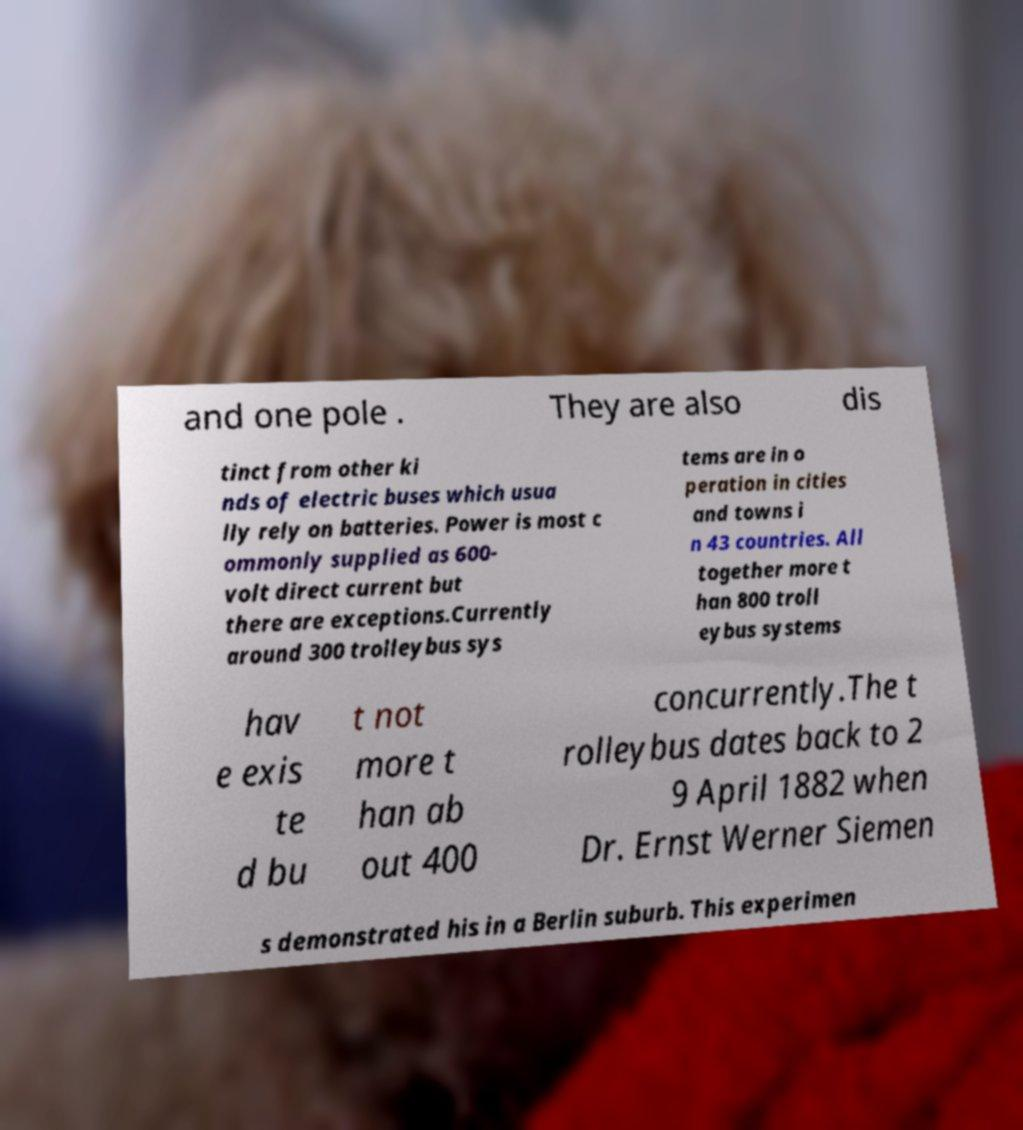Could you assist in decoding the text presented in this image and type it out clearly? and one pole . They are also dis tinct from other ki nds of electric buses which usua lly rely on batteries. Power is most c ommonly supplied as 600- volt direct current but there are exceptions.Currently around 300 trolleybus sys tems are in o peration in cities and towns i n 43 countries. All together more t han 800 troll eybus systems hav e exis te d bu t not more t han ab out 400 concurrently.The t rolleybus dates back to 2 9 April 1882 when Dr. Ernst Werner Siemen s demonstrated his in a Berlin suburb. This experimen 